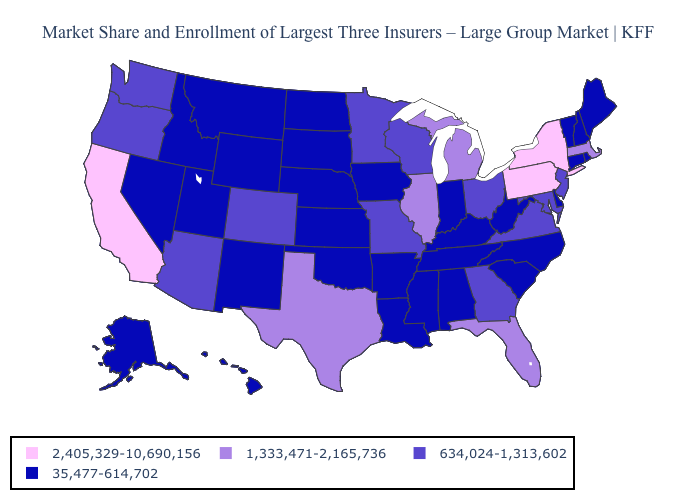Among the states that border Oklahoma , which have the highest value?
Write a very short answer. Texas. What is the highest value in states that border Oregon?
Answer briefly. 2,405,329-10,690,156. Which states have the lowest value in the Northeast?
Keep it brief. Connecticut, Maine, New Hampshire, Rhode Island, Vermont. Does the map have missing data?
Be succinct. No. What is the lowest value in the USA?
Concise answer only. 35,477-614,702. Name the states that have a value in the range 634,024-1,313,602?
Give a very brief answer. Arizona, Colorado, Georgia, Maryland, Minnesota, Missouri, New Jersey, Ohio, Oregon, Virginia, Washington, Wisconsin. What is the lowest value in the USA?
Keep it brief. 35,477-614,702. What is the value of California?
Short answer required. 2,405,329-10,690,156. Is the legend a continuous bar?
Be succinct. No. Does Nevada have the highest value in the USA?
Write a very short answer. No. Which states have the lowest value in the Northeast?
Write a very short answer. Connecticut, Maine, New Hampshire, Rhode Island, Vermont. Among the states that border South Carolina , which have the highest value?
Answer briefly. Georgia. What is the highest value in states that border New York?
Short answer required. 2,405,329-10,690,156. Does Michigan have the lowest value in the USA?
Be succinct. No. Which states have the lowest value in the USA?
Keep it brief. Alabama, Alaska, Arkansas, Connecticut, Delaware, Hawaii, Idaho, Indiana, Iowa, Kansas, Kentucky, Louisiana, Maine, Mississippi, Montana, Nebraska, Nevada, New Hampshire, New Mexico, North Carolina, North Dakota, Oklahoma, Rhode Island, South Carolina, South Dakota, Tennessee, Utah, Vermont, West Virginia, Wyoming. 